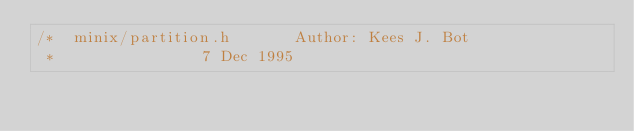Convert code to text. <code><loc_0><loc_0><loc_500><loc_500><_C_>/*	minix/partition.h				Author: Kees J. Bot
 *								7 Dec 1995</code> 